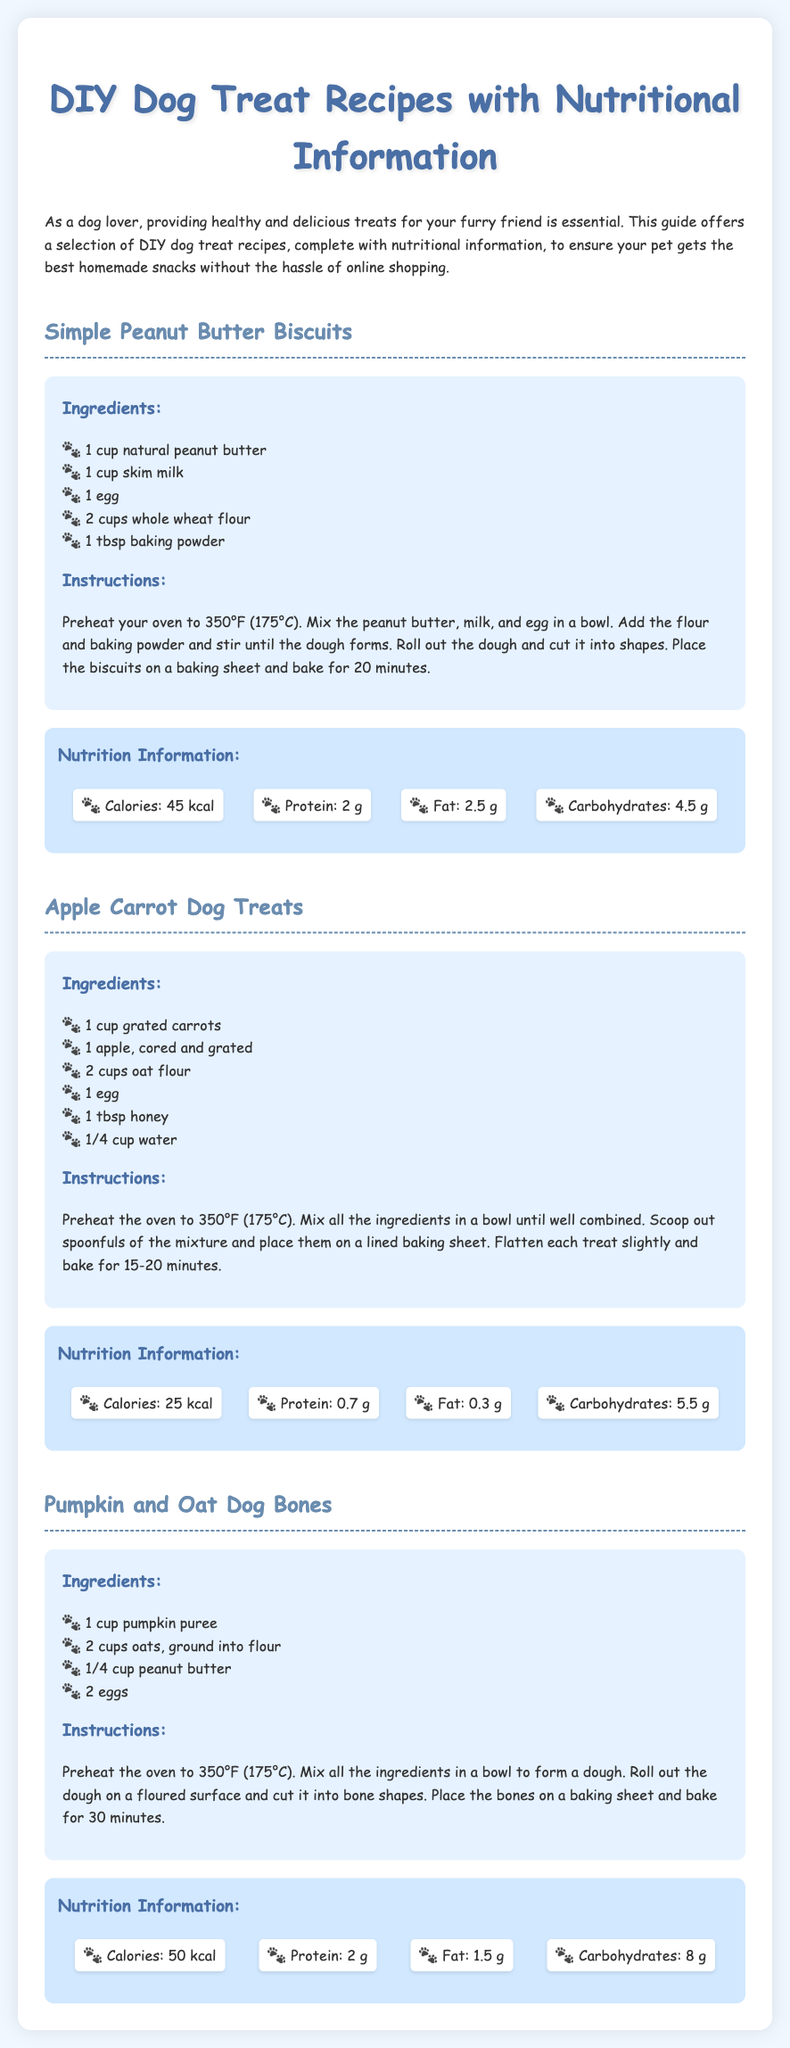what is the title of the document? The title is clearly stated in the HTML markup as "DIY Dog Treat Recipes with Nutritional Information."
Answer: DIY Dog Treat Recipes with Nutritional Information how many ingredients are listed for the Simple Peanut Butter Biscuits? The ingredients for this recipe are counted in the document, where the list contains 5 items.
Answer: 5 what is the main ingredient in Apple Carrot Dog Treats? The main ingredients are highlighted in the list, with grated carrots being one of the key components.
Answer: grated carrots how many calories are in Pumpkin and Oat Dog Bones? The nutrition information is provided, and the calorie count for this recipe is specified as 50 kcal.
Answer: 50 kcal what is the cooking temperature for all recipes? Each recipe mentions the same preheat temperature, which is indicated as 350°F (175°C) in the instructions.
Answer: 350°F (175°C) what is the fat content of the Simple Peanut Butter Biscuits? The nutrition information specifically states the fat content for this recipe as 2.5 g.
Answer: 2.5 g which recipe includes honey? The ingredient lists under the Apple Carrot Dog Treats highlight honey as incorporated into the recipe.
Answer: Apple Carrot Dog Treats what shape are the Pumpkin and Oat Dog Bones cut into? The instructions describe the dough being cut into bone shapes, which indicates the form of the treats.
Answer: bone shapes 